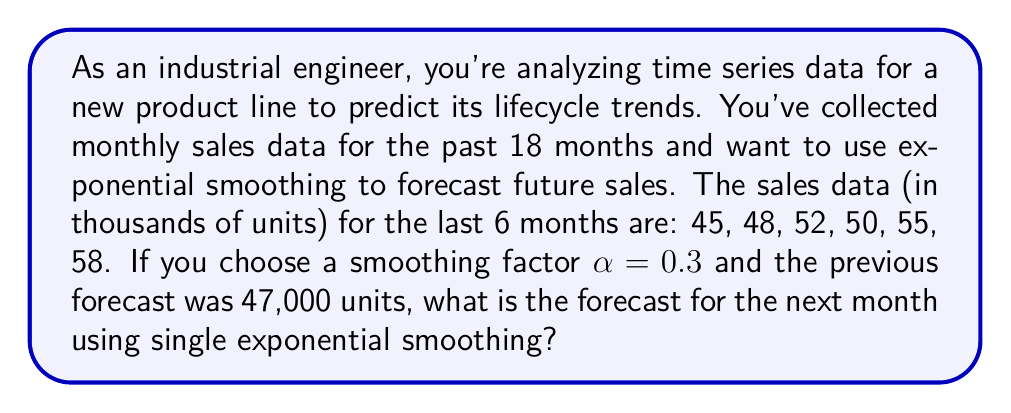Solve this math problem. To solve this problem, we'll use the single exponential smoothing formula:

$$F_{t+1} = \alpha Y_t + (1-\alpha)F_t$$

Where:
$F_{t+1}$ is the forecast for the next period
$\alpha$ is the smoothing factor (0 < α < 1)
$Y_t$ is the actual observation in the current period
$F_t$ is the forecast for the current period

Given:
- α = 0.3
- $Y_t$ (current observation) = 58,000 units
- $F_t$ (previous forecast) = 47,000 units

Let's calculate the forecast for the next month:

$$\begin{align}
F_{t+1} &= 0.3 \times 58,000 + (1-0.3) \times 47,000 \\
&= 17,400 + 0.7 \times 47,000 \\
&= 17,400 + 32,900 \\
&= 50,300
\end{align}$$

This method gives more weight to recent observations while still considering the historical trend, which is crucial for predicting product lifecycle trends. The smoothing factor α = 0.3 indicates a balance between responsiveness to recent changes and stability based on historical data.
Answer: The forecast for the next month using single exponential smoothing is 50,300 units. 